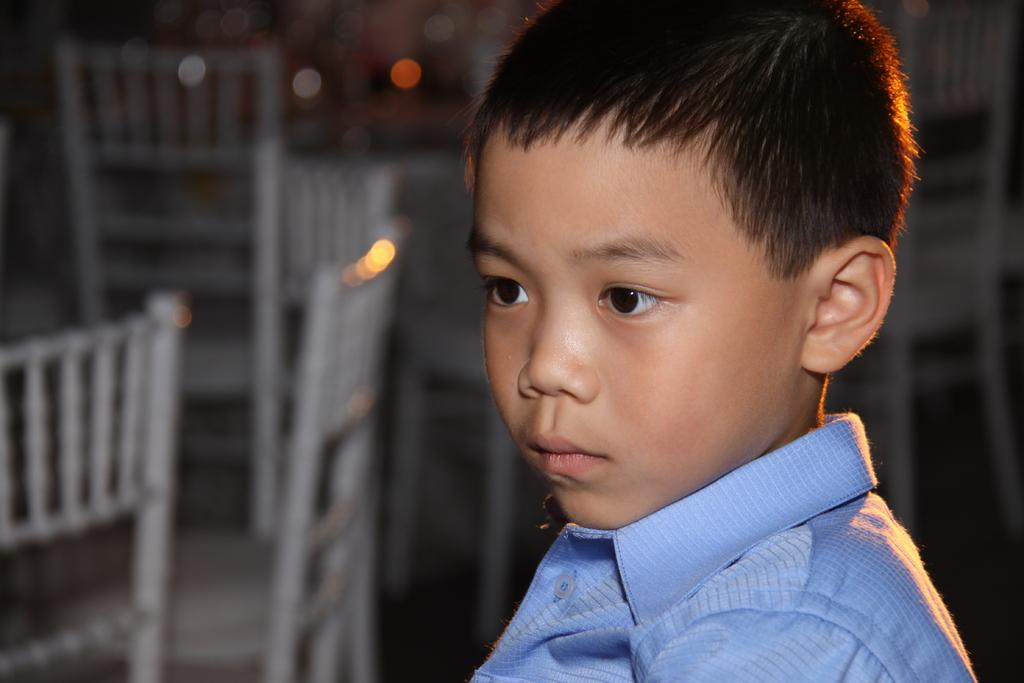Who is the main subject in the image? There is a boy in the image. What can be seen in the background of the image? Chairs are visible in the background of the image. What type of soap is the boy using in the image? There is no soap present in the image; it only features a boy and chairs in the background. 